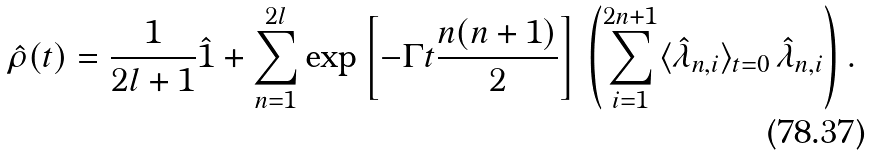<formula> <loc_0><loc_0><loc_500><loc_500>\hat { \rho } ( t ) = \frac { 1 } { 2 l + 1 } \hat { 1 } + \sum _ { n = 1 } ^ { 2 l } \exp \left [ - \Gamma t \frac { n ( n + 1 ) } { 2 } \right ] \, \left ( \sum _ { i = 1 } ^ { 2 n + 1 } \langle \hat { \lambda } _ { n , i } \rangle _ { t = 0 } \, \hat { \lambda } _ { n , i } \right ) .</formula> 